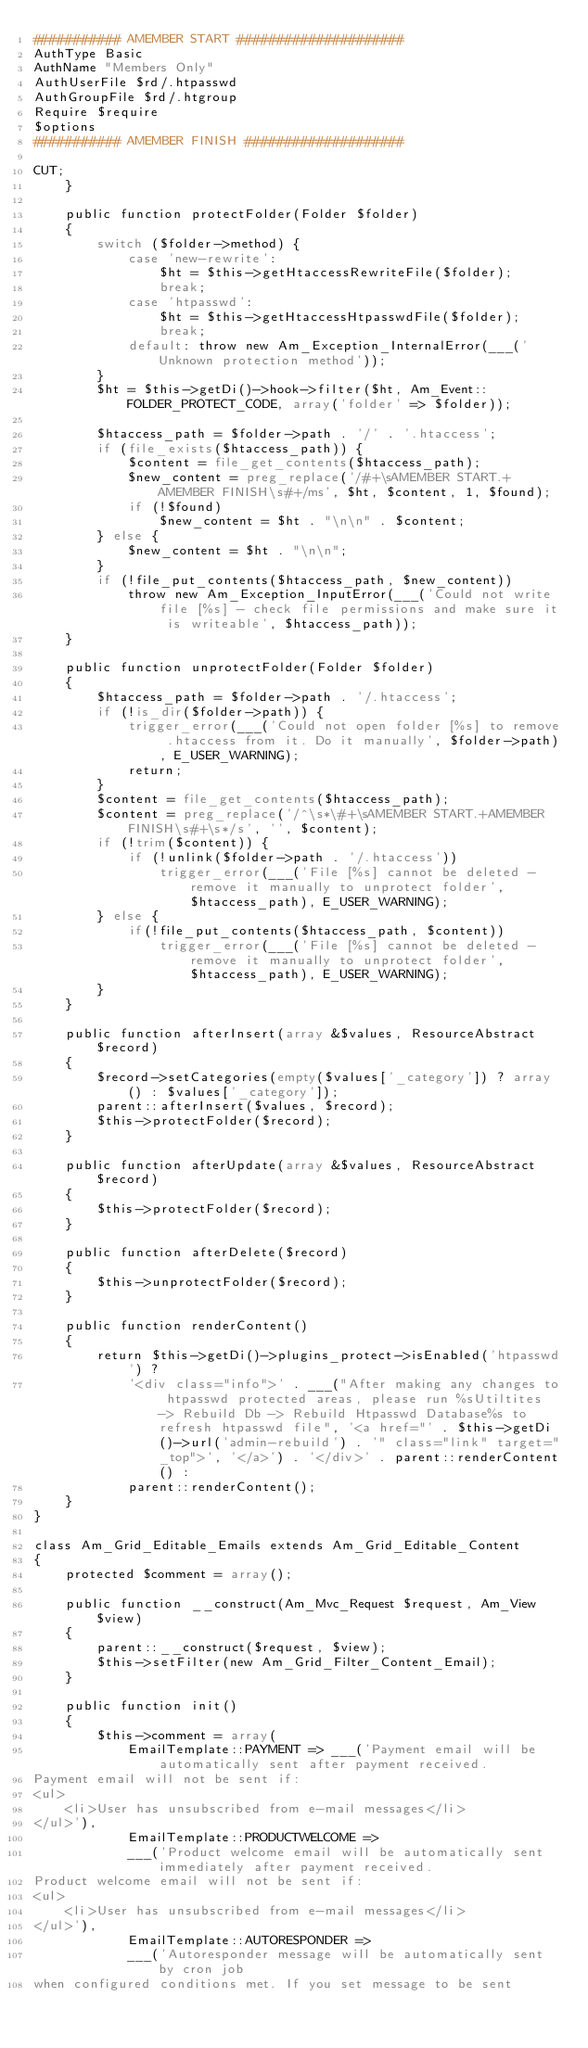<code> <loc_0><loc_0><loc_500><loc_500><_PHP_>########### AMEMBER START #####################
AuthType Basic
AuthName "Members Only"
AuthUserFile $rd/.htpasswd
AuthGroupFile $rd/.htgroup
Require $require
$options
########### AMEMBER FINISH ####################

CUT;
    }

    public function protectFolder(Folder $folder)
    {
        switch ($folder->method) {
            case 'new-rewrite':
                $ht = $this->getHtaccessRewriteFile($folder);
                break;
            case 'htpasswd':
                $ht = $this->getHtaccessHtpasswdFile($folder);
                break;
            default: throw new Am_Exception_InternalError(___('Unknown protection method'));
        }
        $ht = $this->getDi()->hook->filter($ht, Am_Event::FOLDER_PROTECT_CODE, array('folder' => $folder));

        $htaccess_path = $folder->path . '/' . '.htaccess';
        if (file_exists($htaccess_path)) {
            $content = file_get_contents($htaccess_path);
            $new_content = preg_replace('/#+\sAMEMBER START.+AMEMBER FINISH\s#+/ms', $ht, $content, 1, $found);
            if (!$found)
                $new_content = $ht . "\n\n" . $content;
        } else {
            $new_content = $ht . "\n\n";
        }
        if (!file_put_contents($htaccess_path, $new_content))
            throw new Am_Exception_InputError(___('Could not write file [%s] - check file permissions and make sure it is writeable', $htaccess_path));
    }

    public function unprotectFolder(Folder $folder)
    {
        $htaccess_path = $folder->path . '/.htaccess';
        if (!is_dir($folder->path)) {
            trigger_error(___('Could not open folder [%s] to remove .htaccess from it. Do it manually', $folder->path), E_USER_WARNING);
            return;
        }
        $content = file_get_contents($htaccess_path);
        $content = preg_replace('/^\s*\#+\sAMEMBER START.+AMEMBER FINISH\s#+\s*/s', '', $content);
        if (!trim($content)) {
            if (!unlink($folder->path . '/.htaccess'))
                trigger_error(___('File [%s] cannot be deleted - remove it manually to unprotect folder', $htaccess_path), E_USER_WARNING);
        } else {
            if(!file_put_contents($htaccess_path, $content))
                trigger_error(___('File [%s] cannot be deleted - remove it manually to unprotect folder', $htaccess_path), E_USER_WARNING);
        }
    }

    public function afterInsert(array &$values, ResourceAbstract $record)
    {
        $record->setCategories(empty($values['_category']) ? array() : $values['_category']);
        parent::afterInsert($values, $record);
        $this->protectFolder($record);
    }

    public function afterUpdate(array &$values, ResourceAbstract $record)
    {
        $this->protectFolder($record);
    }

    public function afterDelete($record)
    {
        $this->unprotectFolder($record);
    }

    public function renderContent()
    {
        return $this->getDi()->plugins_protect->isEnabled('htpasswd') ?
            '<div class="info">' . ___("After making any changes to htpasswd protected areas, please run %sUtiltites -> Rebuild Db -> Rebuild Htpasswd Database%s to refresh htpasswd file", '<a href="' . $this->getDi()->url('admin-rebuild') . '" class="link" target="_top">', '</a>') . '</div>' . parent::renderContent() :
            parent::renderContent();
    }
}

class Am_Grid_Editable_Emails extends Am_Grid_Editable_Content
{
    protected $comment = array();

    public function __construct(Am_Mvc_Request $request, Am_View $view)
    {
        parent::__construct($request, $view);
        $this->setFilter(new Am_Grid_Filter_Content_Email);
    }

    public function init()
    {
        $this->comment = array(
            EmailTemplate::PAYMENT => ___('Payment email will be automatically sent after payment received.
Payment email will not be sent if:
<ul>
    <li>User has unsubscribed from e-mail messages</li>
</ul>'),
            EmailTemplate::PRODUCTWELCOME =>
            ___('Product welcome email will be automatically sent immediately after payment received.
Product welcome email will not be sent if:
<ul>
    <li>User has unsubscribed from e-mail messages</li>
</ul>'),
            EmailTemplate::AUTORESPONDER =>
            ___('Autoresponder message will be automatically sent by cron job
when configured conditions met. If you set message to be sent</code> 